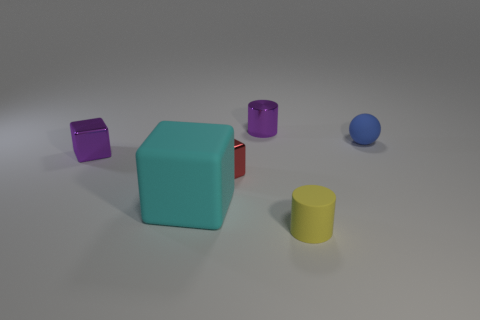Subtract all rubber cubes. How many cubes are left? 2 Add 2 small yellow objects. How many objects exist? 8 Subtract all cylinders. How many objects are left? 4 Subtract 2 cylinders. How many cylinders are left? 0 Subtract all purple cubes. How many cubes are left? 2 Add 4 cyan blocks. How many cyan blocks exist? 5 Subtract 0 brown balls. How many objects are left? 6 Subtract all purple balls. Subtract all purple cubes. How many balls are left? 1 Subtract all tiny rubber balls. Subtract all red metal cubes. How many objects are left? 4 Add 3 tiny yellow rubber cylinders. How many tiny yellow rubber cylinders are left? 4 